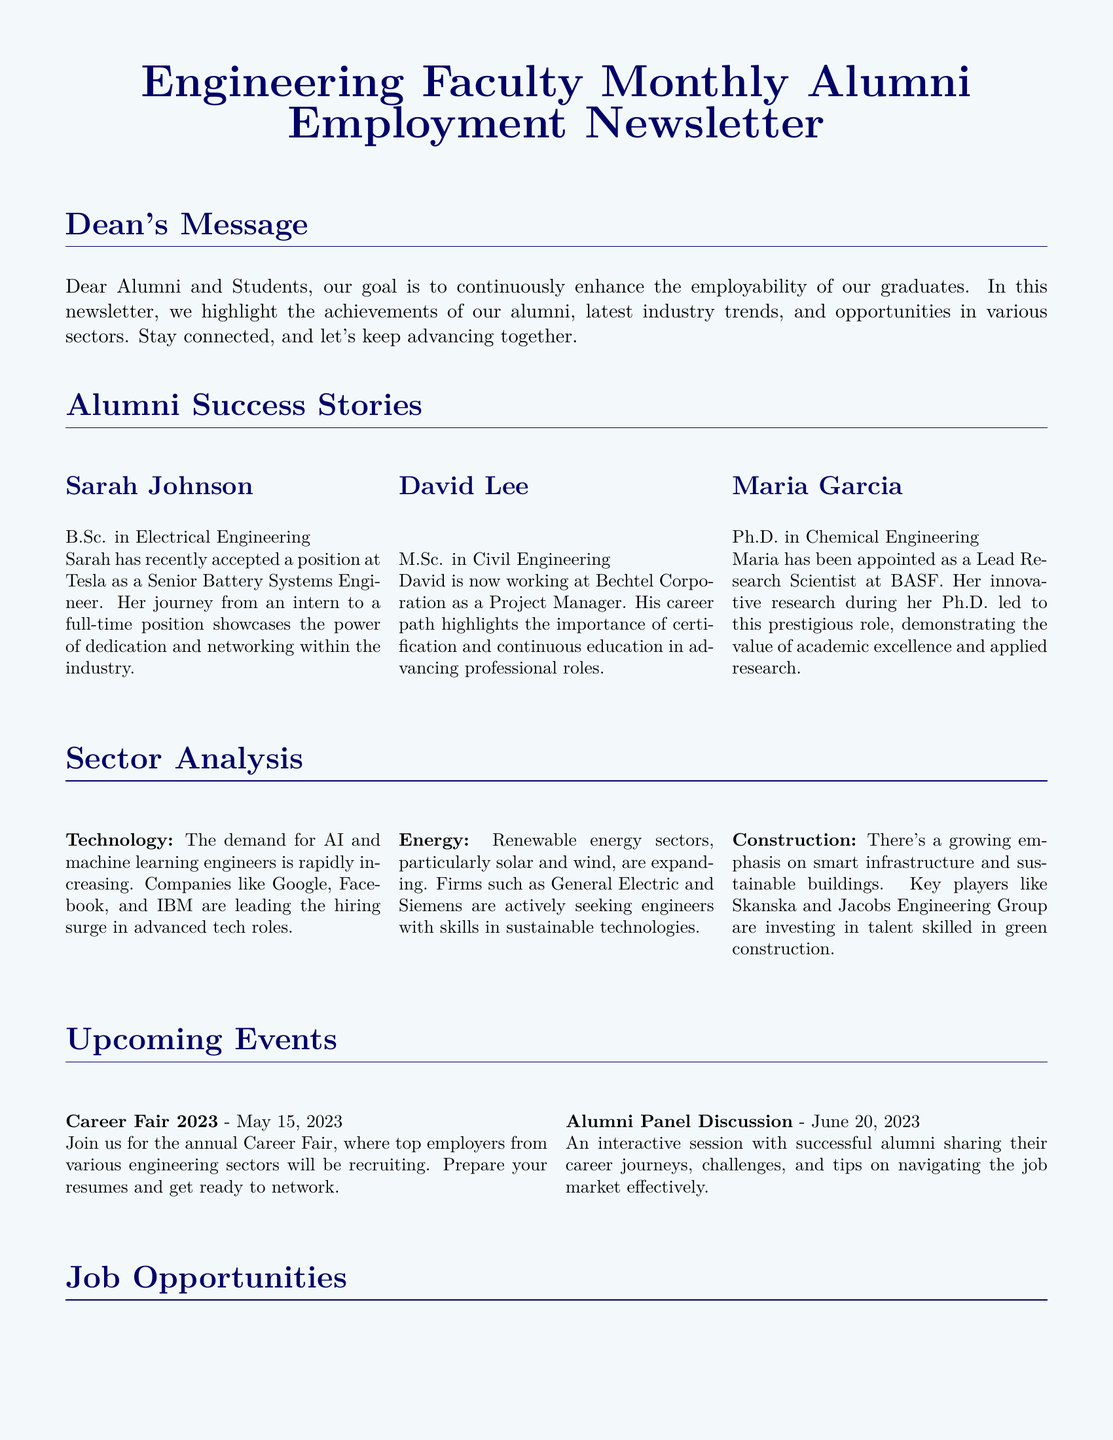What position did Sarah Johnson accept? Sarah Johnson accepted a position at Tesla as a Senior Battery Systems Engineer, which is detailed in her success story.
Answer: Senior Battery Systems Engineer Who is the Project Manager at Bechtel Corporation? David Lee is recognized as the Project Manager at Bechtel Corporation in the alumni success stories section.
Answer: David Lee What date is the Career Fair 2023 scheduled? The Career Fair 2023 is scheduled for May 15, 2023, as mentioned in the upcoming events section.
Answer: May 15, 2023 What sector is experiencing a demand for engineers skilled in sustainable technologies? The energy sector, particularly in renewable sectors like solar and wind, is noted for seeking engineers with these skills in the sector analysis.
Answer: Energy Which company is mentioned as seeking Software Development Engineers? Amazon is specifically mentioned as looking for experienced software engineers in the job opportunities section.
Answer: Amazon What is the educational qualification of Maria Garcia? Maria Garcia holds a Ph.D. in Chemical Engineering, which is specified in her success story.
Answer: Ph.D. in Chemical Engineering Which two companies are highlighted for hiring in the construction sector? Skanska and Jacobs Engineering Group are the two companies highlighted for investing in talent for the construction sector.
Answer: Skanska and Jacobs Engineering Group What is the main focus for the Electrical Design Engineer position at Lockheed Martin? The focus is on electrical systems design for aerospace applications, as indicated in the job opportunities section.
Answer: Aerospace applications What is the primary goal of the newsletter as stated by the Dean? The primary goal is to continuously enhance the employability of graduates, as expressed in the Dean's message.
Answer: Enhance employability 